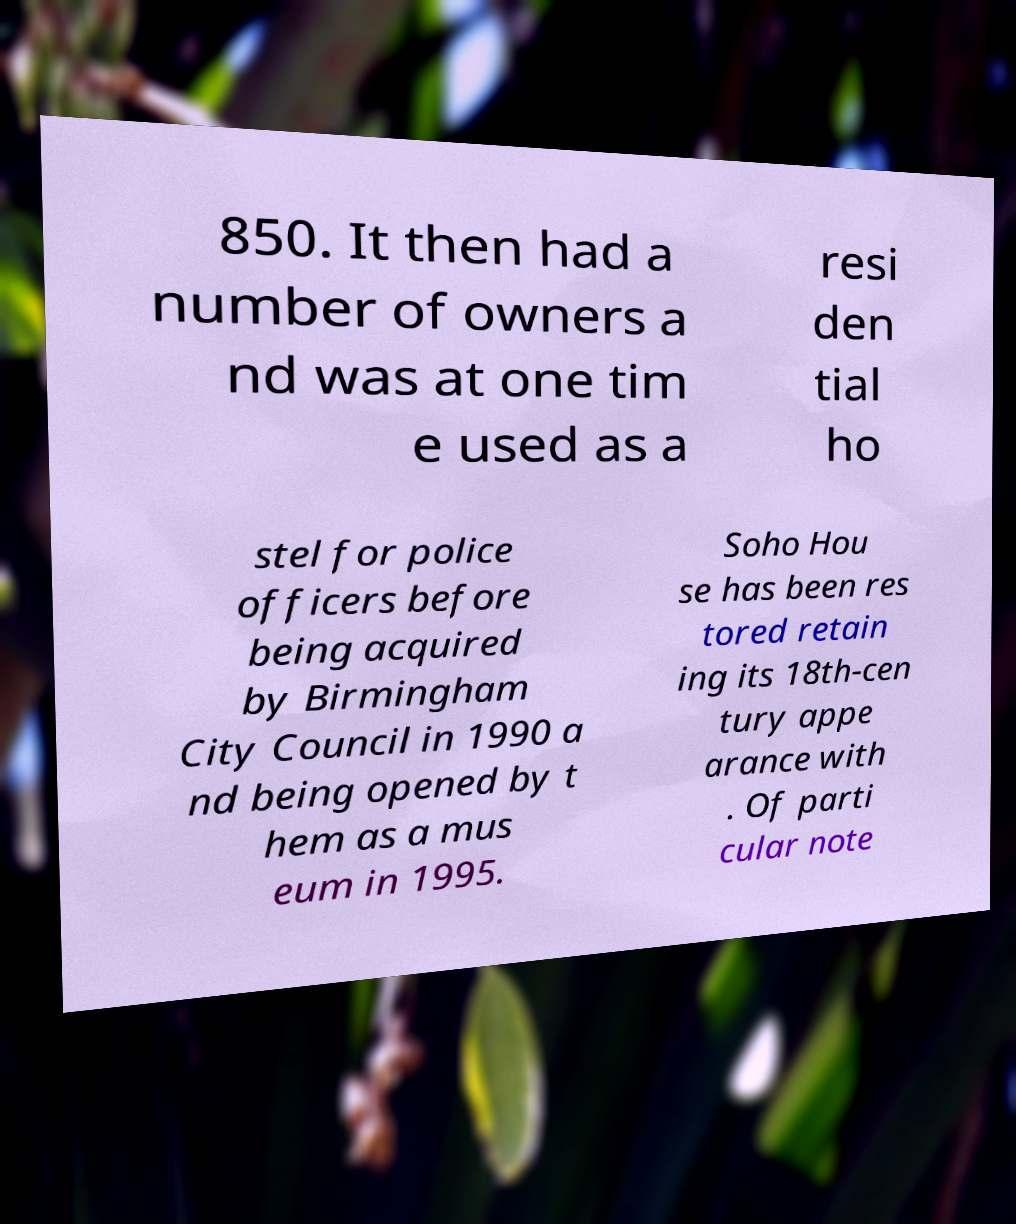Could you assist in decoding the text presented in this image and type it out clearly? 850. It then had a number of owners a nd was at one tim e used as a resi den tial ho stel for police officers before being acquired by Birmingham City Council in 1990 a nd being opened by t hem as a mus eum in 1995. Soho Hou se has been res tored retain ing its 18th-cen tury appe arance with . Of parti cular note 